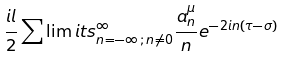<formula> <loc_0><loc_0><loc_500><loc_500>\frac { i l } { 2 } \sum \lim i t s _ { n = - \infty \, ; \, n \neq 0 } ^ { \infty } \frac { a ^ { \mu } _ { n } } { n } e ^ { - 2 i n ( \tau - \sigma ) }</formula> 